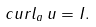Convert formula to latex. <formula><loc_0><loc_0><loc_500><loc_500>c u r l _ { a } \, { u = I } .</formula> 